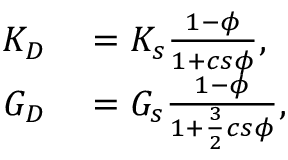Convert formula to latex. <formula><loc_0><loc_0><loc_500><loc_500>\begin{array} { r l } { K _ { D } } & = K _ { s } \frac { 1 - \phi } { 1 + c s \phi } , } \\ { G _ { D } } & = G _ { s } \frac { 1 - \phi } { 1 + \frac { 3 } { 2 } c s \phi } , } \end{array}</formula> 